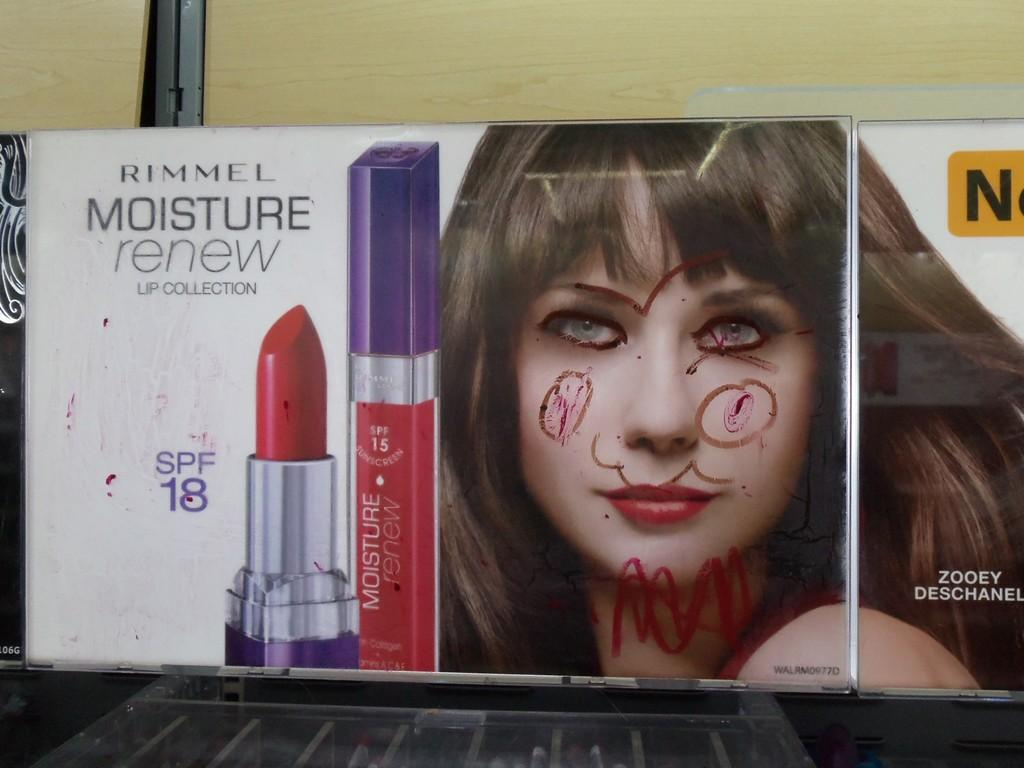What is the main object in the image? There is an advertisement board in the image. What is depicted on the advertisement board? The advertisement board contains a person and lipstick. How many ants can be seen crawling on the person's face in the image? There are no ants present in the image; the advertisement board contains a person and lipstick. What type of heart is shown on the advertisement board? There is no heart depicted on the advertisement board; it contains a person and lipstick. 